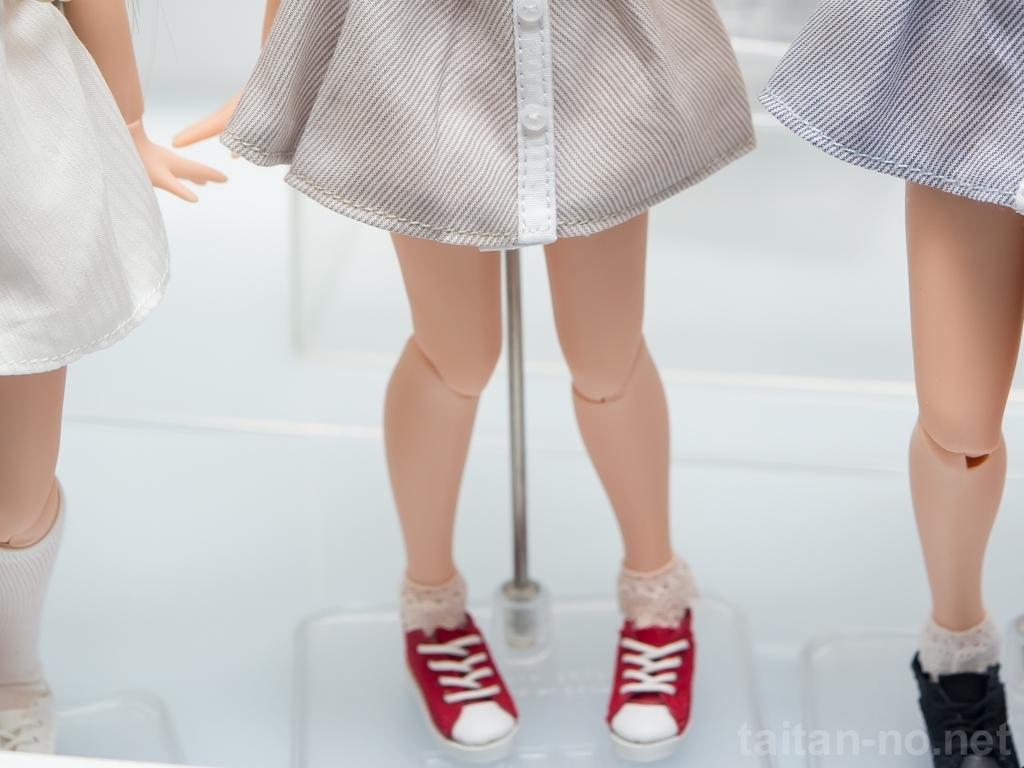What details can you tell me about the outfits of the figures in the image? The figures are dressed in what appears to be stylish, perhaps even high-fashion dresses. One dress has a sleek, white or light-colored fabric with a subtle pattern, while the other incorporates a textured fabric in a shade of grey, both with an A-line silhouette. The attention to detail extends to the accessories with both figures wearing lace-trimmed socks and casual, yet trendy sneakers, one pair in red and the other in black. This juxtaposition of elegant dress attire with sporty footwear could suggest a modern, edgy fashion statement. 